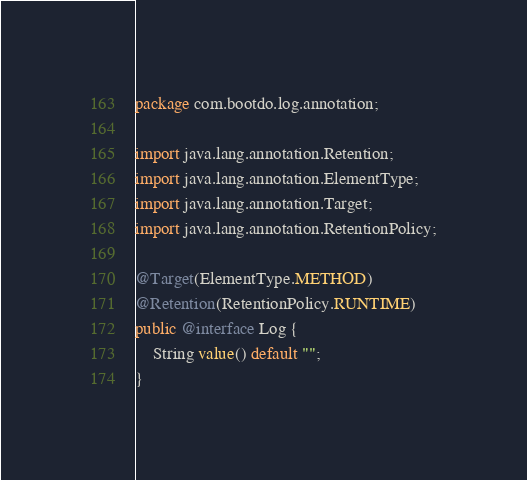Convert code to text. <code><loc_0><loc_0><loc_500><loc_500><_Java_>package com.bootdo.log.annotation;

import java.lang.annotation.Retention;
import java.lang.annotation.ElementType;
import java.lang.annotation.Target;
import java.lang.annotation.RetentionPolicy;

@Target(ElementType.METHOD)
@Retention(RetentionPolicy.RUNTIME)
public @interface Log {
	String value() default "";
}
</code> 